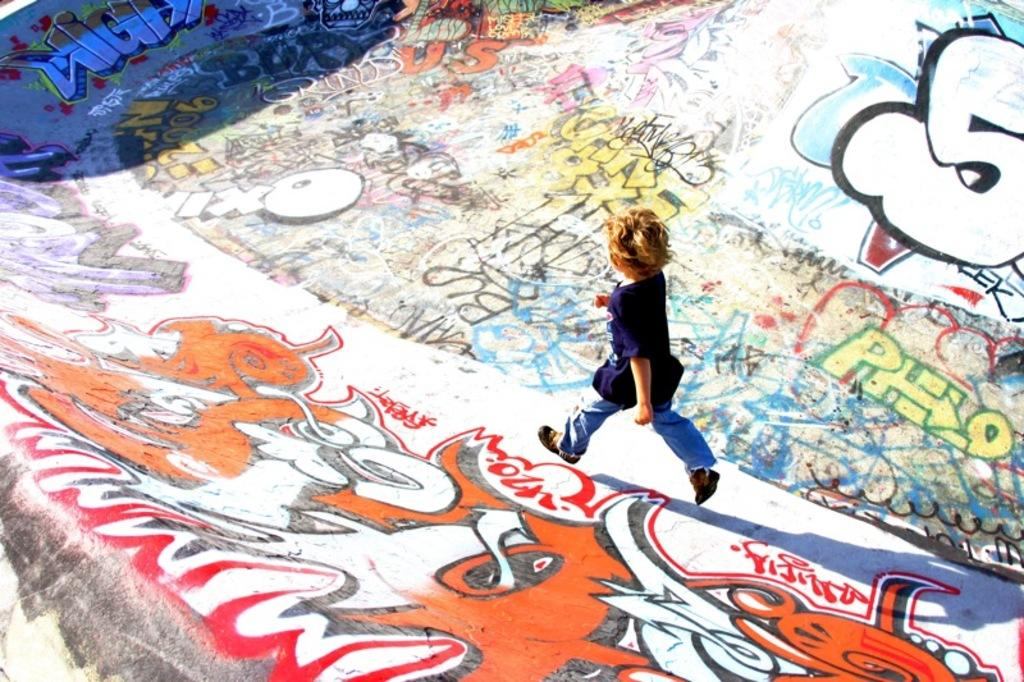What is the main subject of the image? The main subject of the image is a kid. What is the kid doing in the image? The kid is walking. What can be seen on the floor in the image? There is graffiti on the floor in the image. How does the kid generate heat while walking in the image? The image does not provide information about the kid generating heat while walking. Is there any indication that the graffiti on the floor is a copy of another artwork in the image? The image does not provide information about the graffiti being a copy of another artwork. 